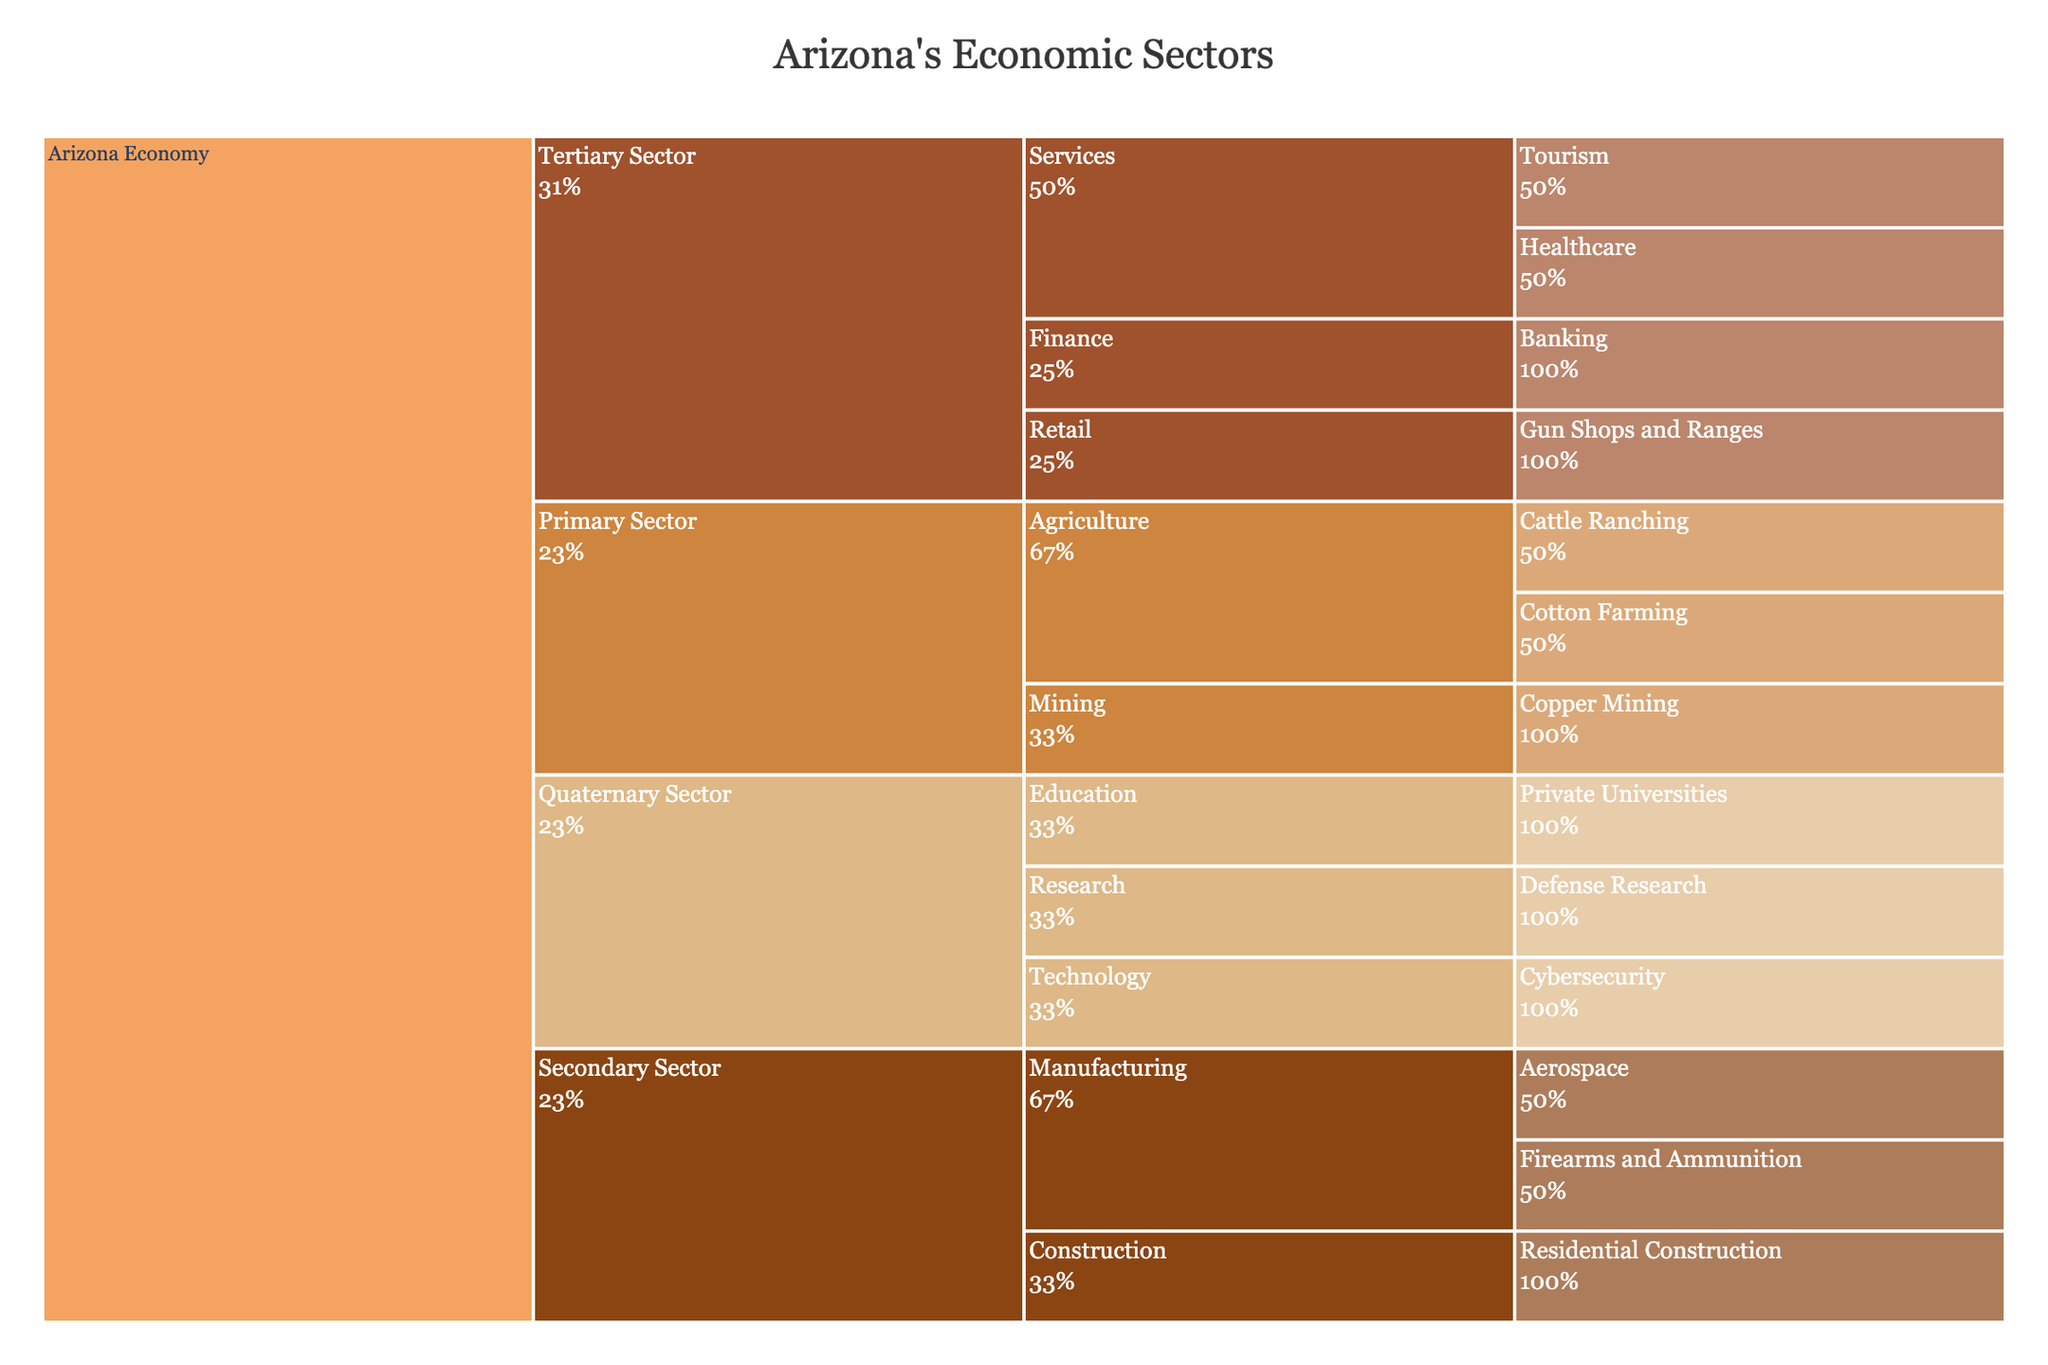What is the title of the chart? The title of the chart is generally placed at the top and is usually one of the most noticeable components. In this case, the title of the Icicle Chart is "Arizona's Economic Sectors".
Answer: Arizona's Economic Sectors Which sub-sector under the Tertiary Sector is related to healthcare? By examining the different sectors and sub-sectors, we can find that the Healthcare industry falls under the Services sub-sector within the Tertiary Sector.
Answer: Services How many primary sectors are represented in the chart? The primary sectors are categorized as 'Primary Sector,' 'Secondary Sector,' 'Tertiary Sector,' and 'Quaternary Sector.' By counting these categories, we find there are four primary sectors in the chart.
Answer: Four What industry is categorized under the sub-sector "Manufacturing" in the Secondary Sector and related to gun ownership? By locating the "Manufacturing" sub-sector under the Secondary Sector, we can see that "Firearms and Ammunition" is the industry related to gun ownership.
Answer: Firearms and Ammunition Which sector contains the "Gun Shops and Ranges" industry? Upon examining the hierarchy of the chart, the "Gun Shops and Ranges" industry is found under the Tertiary Sector, within the Retail sub-sector.
Answer: Tertiary Sector Which category has the most sub-sectors? To answer this, we review each primary sector and count the sub-sectors they contain. The Tertiary Sector, which includes Services, Retail, and Finance, has the most sub-sectors.
Answer: Tertiary Sector What percentage of the parent category does the Cybersecurity industry represent? Since each industry is weighted equally in the Icicle Chart, every industry within a sub-sector equally divides the percentage of its parent category. Since Technology under the Quaternary Sector has only Cybersecurity listed, Cybersecurity represents 100% of its parent category.
Answer: 100% Which sector is related to both "Defense Research" and "Private Universities"? Both "Defense Research" and "Private Universities" are categorized under the sub-sectors within the Quaternary Sector, specifically under the Research and Education sub-sectors respectively.
Answer: Quaternary Sector Compare the number of industries in the Primary Sector versus the Secondary Sector. Which one has more industries? By counting the industries in each sector, the Primary Sector has three industries (Cattle Ranching, Cotton Farming, Copper Mining), while the Secondary Sector has three industries (Aerospace, Firearms and Ammunition, Residential Construction). Both sectors contain the same number of industries.
Answer: Equal What is the sub-sector under the Quaternary Sector related to "Cybersecurity"? By tracing the path under the Quaternary Sector, we find "Cybersecurity" is categorized under the Technology sub-sector.
Answer: Technology 